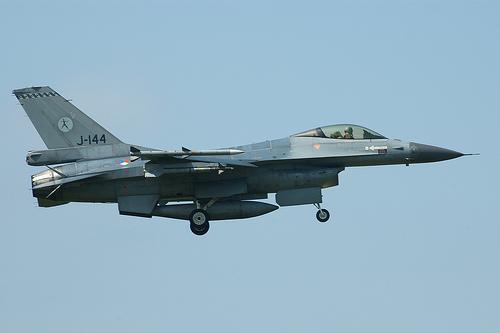How many people are in this picture?
Give a very brief answer. 1. 